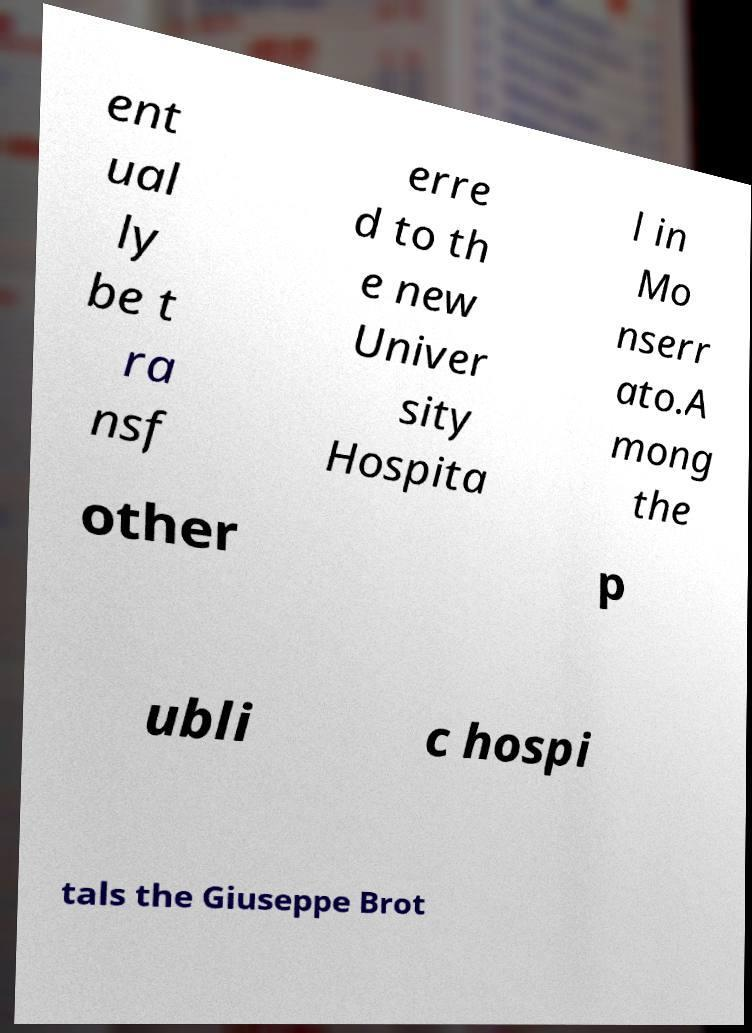Could you extract and type out the text from this image? ent ual ly be t ra nsf erre d to th e new Univer sity Hospita l in Mo nserr ato.A mong the other p ubli c hospi tals the Giuseppe Brot 